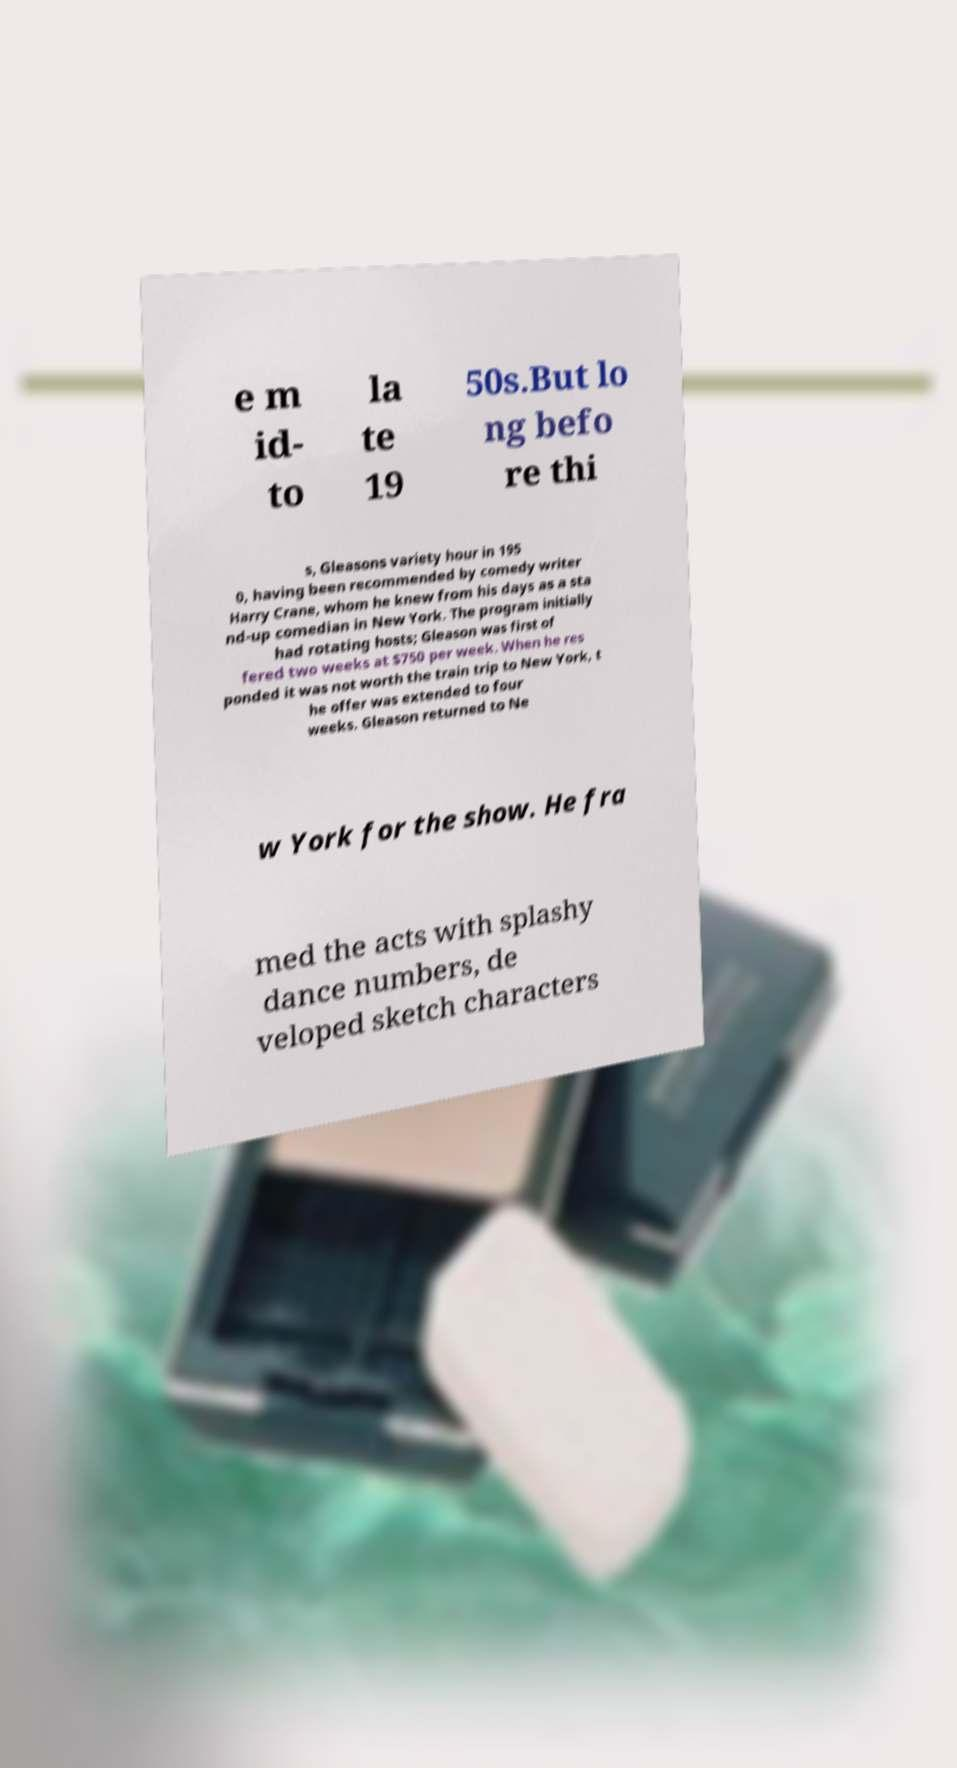Please read and relay the text visible in this image. What does it say? e m id- to la te 19 50s.But lo ng befo re thi s, Gleasons variety hour in 195 0, having been recommended by comedy writer Harry Crane, whom he knew from his days as a sta nd-up comedian in New York. The program initially had rotating hosts; Gleason was first of fered two weeks at $750 per week. When he res ponded it was not worth the train trip to New York, t he offer was extended to four weeks. Gleason returned to Ne w York for the show. He fra med the acts with splashy dance numbers, de veloped sketch characters 